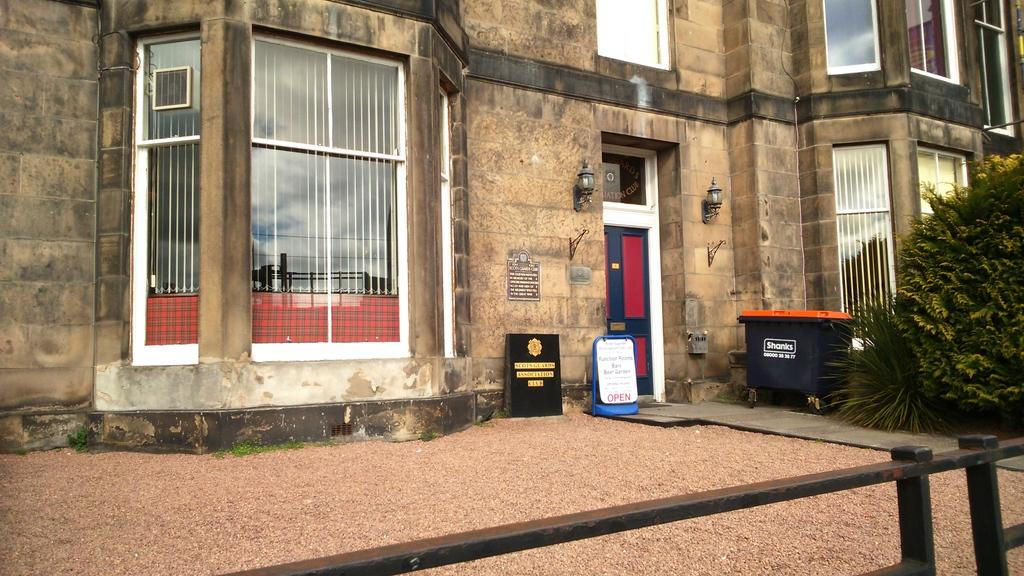What type of building is in the image? There is a cream-colored building in the image. What feature can be seen on the building? The building has glass windows. Can you describe the entrance to the building? There is a door in the image. What objects are present in the image that might be used for displaying information or advertisements? There are boards in the image. What can be seen illuminating the area in the image? There are lights in the image. What type of container is visible in the image? There is a container in the image. What type of greenery is present in the image? There are plants in the image. What is written on the boards in the image? There is writing on the boards. How many apples are on the table in the image? There are no apples present in the image. What type of paper is being used to cover the car in the image? There is no car or paper present in the image. 